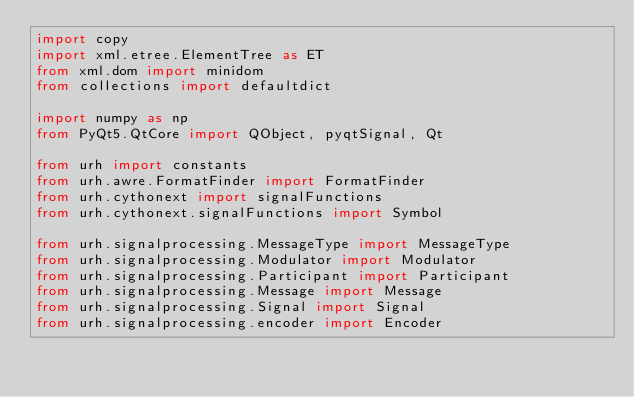Convert code to text. <code><loc_0><loc_0><loc_500><loc_500><_Python_>import copy
import xml.etree.ElementTree as ET
from xml.dom import minidom
from collections import defaultdict

import numpy as np
from PyQt5.QtCore import QObject, pyqtSignal, Qt

from urh import constants
from urh.awre.FormatFinder import FormatFinder
from urh.cythonext import signalFunctions
from urh.cythonext.signalFunctions import Symbol

from urh.signalprocessing.MessageType import MessageType
from urh.signalprocessing.Modulator import Modulator
from urh.signalprocessing.Participant import Participant
from urh.signalprocessing.Message import Message
from urh.signalprocessing.Signal import Signal
from urh.signalprocessing.encoder import Encoder</code> 